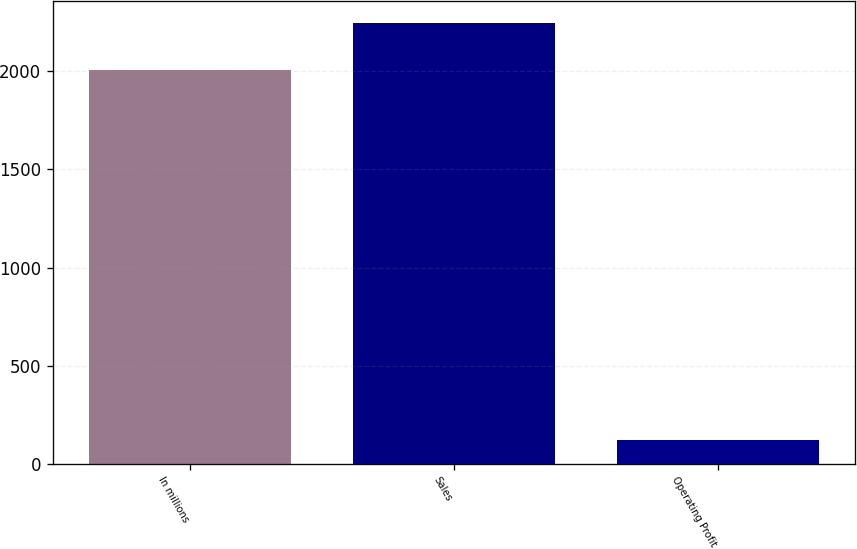Convert chart to OTSL. <chart><loc_0><loc_0><loc_500><loc_500><bar_chart><fcel>In millions<fcel>Sales<fcel>Operating Profit<nl><fcel>2005<fcel>2245<fcel>121<nl></chart> 